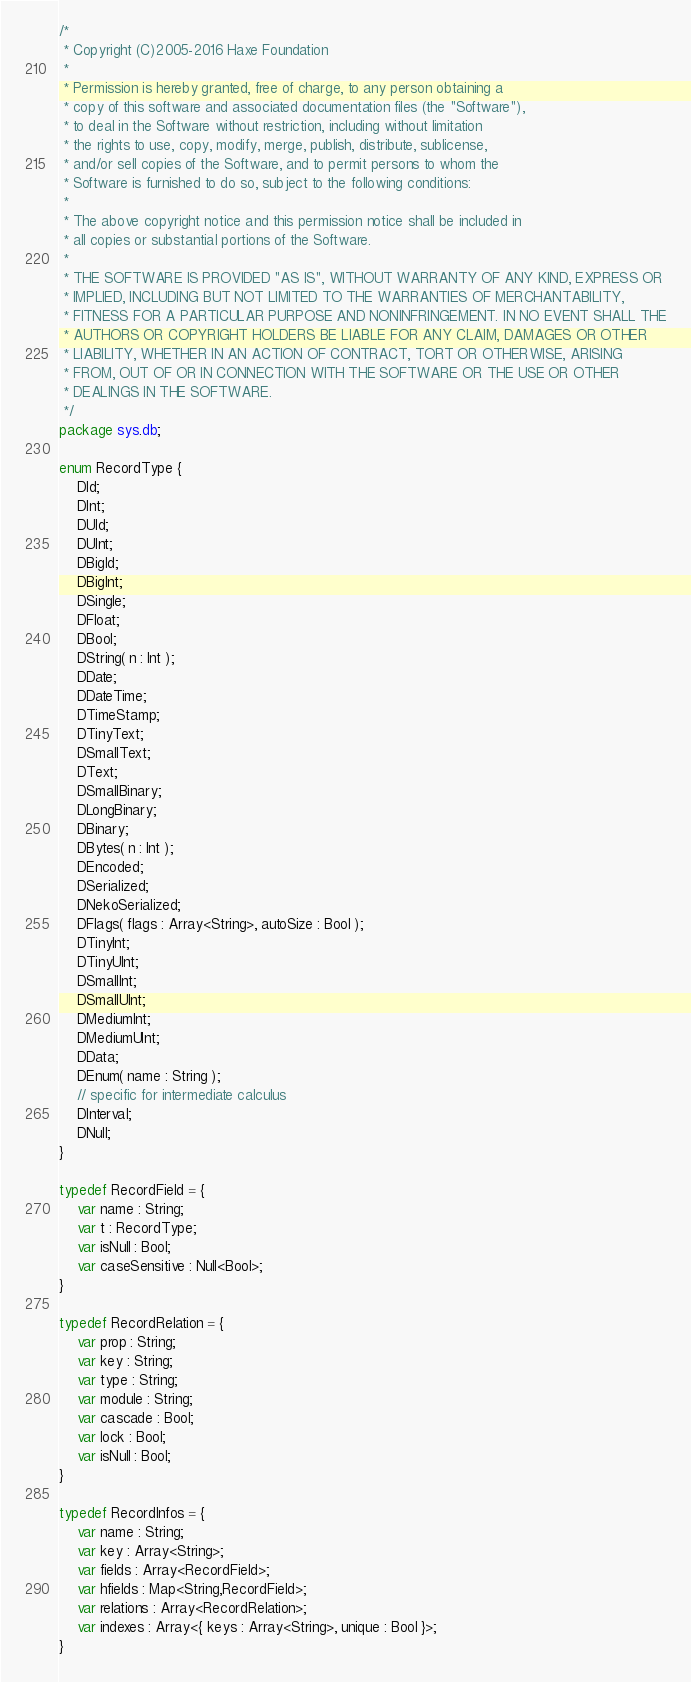<code> <loc_0><loc_0><loc_500><loc_500><_Haxe_>/*
 * Copyright (C)2005-2016 Haxe Foundation
 *
 * Permission is hereby granted, free of charge, to any person obtaining a
 * copy of this software and associated documentation files (the "Software"),
 * to deal in the Software without restriction, including without limitation
 * the rights to use, copy, modify, merge, publish, distribute, sublicense,
 * and/or sell copies of the Software, and to permit persons to whom the
 * Software is furnished to do so, subject to the following conditions:
 *
 * The above copyright notice and this permission notice shall be included in
 * all copies or substantial portions of the Software.
 *
 * THE SOFTWARE IS PROVIDED "AS IS", WITHOUT WARRANTY OF ANY KIND, EXPRESS OR
 * IMPLIED, INCLUDING BUT NOT LIMITED TO THE WARRANTIES OF MERCHANTABILITY,
 * FITNESS FOR A PARTICULAR PURPOSE AND NONINFRINGEMENT. IN NO EVENT SHALL THE
 * AUTHORS OR COPYRIGHT HOLDERS BE LIABLE FOR ANY CLAIM, DAMAGES OR OTHER
 * LIABILITY, WHETHER IN AN ACTION OF CONTRACT, TORT OR OTHERWISE, ARISING
 * FROM, OUT OF OR IN CONNECTION WITH THE SOFTWARE OR THE USE OR OTHER
 * DEALINGS IN THE SOFTWARE.
 */
package sys.db;

enum RecordType {
	DId;
	DInt;
	DUId;
	DUInt;
	DBigId;
	DBigInt;
	DSingle;
	DFloat;
	DBool;
	DString( n : Int );
	DDate;
	DDateTime;
	DTimeStamp;
	DTinyText;
	DSmallText;
	DText;
	DSmallBinary;
	DLongBinary;
	DBinary;
	DBytes( n : Int );
	DEncoded;
	DSerialized;
	DNekoSerialized;
	DFlags( flags : Array<String>, autoSize : Bool );
	DTinyInt;
	DTinyUInt;
	DSmallInt;
	DSmallUInt;
	DMediumInt;
	DMediumUInt;
	DData;
	DEnum( name : String );
	// specific for intermediate calculus
	DInterval;
	DNull;
}

typedef RecordField = {
	var name : String;
	var t : RecordType;
	var isNull : Bool;
	var caseSensitive : Null<Bool>;
}

typedef RecordRelation = {
	var prop : String;
	var key : String;
	var type : String;
	var module : String;
	var cascade : Bool;
	var lock : Bool;
	var isNull : Bool;
}

typedef RecordInfos = {
	var name : String;
	var key : Array<String>;
	var fields : Array<RecordField>;
	var hfields : Map<String,RecordField>;
	var relations : Array<RecordRelation>;
	var indexes : Array<{ keys : Array<String>, unique : Bool }>;
}
</code> 